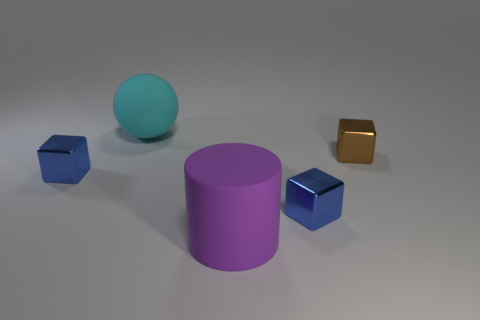Add 3 large purple cylinders. How many objects exist? 8 Subtract all brown metallic cubes. How many cubes are left? 2 Subtract 1 cylinders. How many cylinders are left? 0 Subtract all cyan spheres. How many blue cubes are left? 2 Subtract all brown cubes. How many cubes are left? 2 Subtract all balls. How many objects are left? 4 Subtract all cyan shiny blocks. Subtract all brown shiny things. How many objects are left? 4 Add 5 large rubber cylinders. How many large rubber cylinders are left? 6 Add 2 red cylinders. How many red cylinders exist? 2 Subtract 0 red spheres. How many objects are left? 5 